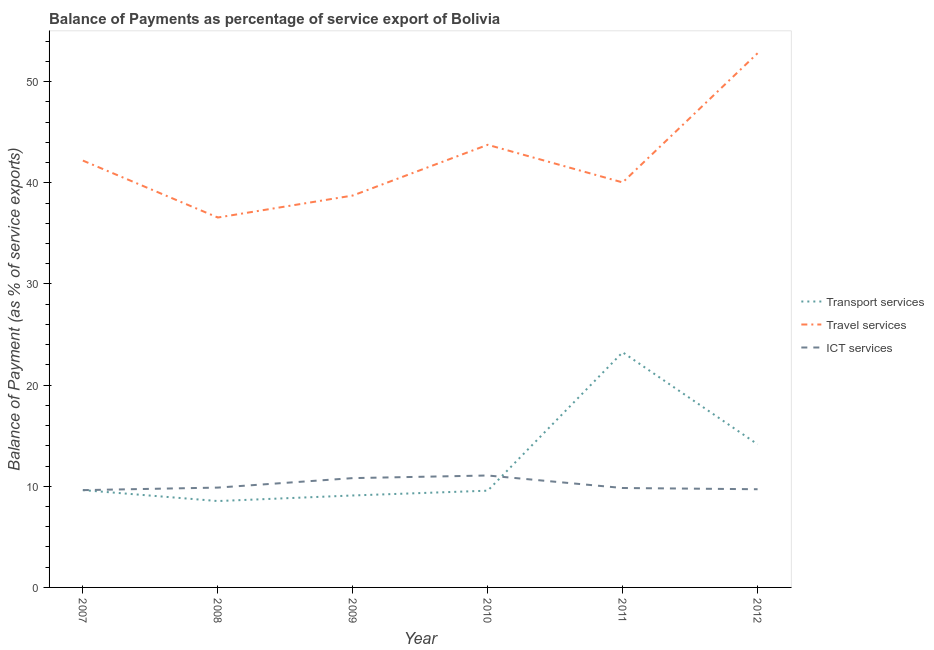What is the balance of payment of transport services in 2010?
Offer a terse response. 9.57. Across all years, what is the maximum balance of payment of ict services?
Keep it short and to the point. 11.07. Across all years, what is the minimum balance of payment of transport services?
Provide a short and direct response. 8.54. In which year was the balance of payment of ict services maximum?
Offer a very short reply. 2010. In which year was the balance of payment of transport services minimum?
Your response must be concise. 2008. What is the total balance of payment of transport services in the graph?
Offer a terse response. 74.21. What is the difference between the balance of payment of transport services in 2007 and that in 2011?
Your response must be concise. -13.63. What is the difference between the balance of payment of transport services in 2012 and the balance of payment of travel services in 2009?
Provide a succinct answer. -24.6. What is the average balance of payment of ict services per year?
Offer a terse response. 10.15. In the year 2009, what is the difference between the balance of payment of transport services and balance of payment of ict services?
Your answer should be compact. -1.72. What is the ratio of the balance of payment of travel services in 2008 to that in 2012?
Offer a very short reply. 0.69. Is the difference between the balance of payment of travel services in 2007 and 2012 greater than the difference between the balance of payment of transport services in 2007 and 2012?
Provide a succinct answer. No. What is the difference between the highest and the second highest balance of payment of transport services?
Make the answer very short. 9.1. What is the difference between the highest and the lowest balance of payment of transport services?
Offer a very short reply. 14.71. Is it the case that in every year, the sum of the balance of payment of transport services and balance of payment of travel services is greater than the balance of payment of ict services?
Offer a very short reply. Yes. Does the balance of payment of transport services monotonically increase over the years?
Your response must be concise. No. Is the balance of payment of ict services strictly greater than the balance of payment of transport services over the years?
Ensure brevity in your answer.  No. Is the balance of payment of ict services strictly less than the balance of payment of travel services over the years?
Keep it short and to the point. Yes. How many lines are there?
Ensure brevity in your answer.  3. What is the difference between two consecutive major ticks on the Y-axis?
Give a very brief answer. 10. Are the values on the major ticks of Y-axis written in scientific E-notation?
Give a very brief answer. No. Does the graph contain grids?
Keep it short and to the point. No. Where does the legend appear in the graph?
Give a very brief answer. Center right. How many legend labels are there?
Your answer should be very brief. 3. How are the legend labels stacked?
Ensure brevity in your answer.  Vertical. What is the title of the graph?
Your response must be concise. Balance of Payments as percentage of service export of Bolivia. Does "Labor Tax" appear as one of the legend labels in the graph?
Your answer should be very brief. No. What is the label or title of the X-axis?
Provide a succinct answer. Year. What is the label or title of the Y-axis?
Your response must be concise. Balance of Payment (as % of service exports). What is the Balance of Payment (as % of service exports) of Transport services in 2007?
Keep it short and to the point. 9.62. What is the Balance of Payment (as % of service exports) in Travel services in 2007?
Provide a succinct answer. 42.2. What is the Balance of Payment (as % of service exports) in ICT services in 2007?
Your response must be concise. 9.62. What is the Balance of Payment (as % of service exports) in Transport services in 2008?
Make the answer very short. 8.54. What is the Balance of Payment (as % of service exports) in Travel services in 2008?
Provide a short and direct response. 36.57. What is the Balance of Payment (as % of service exports) of ICT services in 2008?
Ensure brevity in your answer.  9.87. What is the Balance of Payment (as % of service exports) of Transport services in 2009?
Give a very brief answer. 9.09. What is the Balance of Payment (as % of service exports) in Travel services in 2009?
Your response must be concise. 38.75. What is the Balance of Payment (as % of service exports) of ICT services in 2009?
Your answer should be very brief. 10.81. What is the Balance of Payment (as % of service exports) of Transport services in 2010?
Offer a terse response. 9.57. What is the Balance of Payment (as % of service exports) in Travel services in 2010?
Offer a terse response. 43.76. What is the Balance of Payment (as % of service exports) of ICT services in 2010?
Provide a succinct answer. 11.07. What is the Balance of Payment (as % of service exports) of Transport services in 2011?
Make the answer very short. 23.25. What is the Balance of Payment (as % of service exports) in Travel services in 2011?
Ensure brevity in your answer.  40.04. What is the Balance of Payment (as % of service exports) in ICT services in 2011?
Offer a terse response. 9.83. What is the Balance of Payment (as % of service exports) in Transport services in 2012?
Ensure brevity in your answer.  14.15. What is the Balance of Payment (as % of service exports) in Travel services in 2012?
Provide a short and direct response. 52.82. What is the Balance of Payment (as % of service exports) of ICT services in 2012?
Provide a short and direct response. 9.71. Across all years, what is the maximum Balance of Payment (as % of service exports) in Transport services?
Make the answer very short. 23.25. Across all years, what is the maximum Balance of Payment (as % of service exports) in Travel services?
Make the answer very short. 52.82. Across all years, what is the maximum Balance of Payment (as % of service exports) in ICT services?
Provide a short and direct response. 11.07. Across all years, what is the minimum Balance of Payment (as % of service exports) in Transport services?
Your answer should be compact. 8.54. Across all years, what is the minimum Balance of Payment (as % of service exports) of Travel services?
Provide a succinct answer. 36.57. Across all years, what is the minimum Balance of Payment (as % of service exports) in ICT services?
Provide a short and direct response. 9.62. What is the total Balance of Payment (as % of service exports) in Transport services in the graph?
Keep it short and to the point. 74.21. What is the total Balance of Payment (as % of service exports) of Travel services in the graph?
Provide a short and direct response. 254.14. What is the total Balance of Payment (as % of service exports) in ICT services in the graph?
Offer a very short reply. 60.9. What is the difference between the Balance of Payment (as % of service exports) in Transport services in 2007 and that in 2008?
Keep it short and to the point. 1.08. What is the difference between the Balance of Payment (as % of service exports) in Travel services in 2007 and that in 2008?
Provide a succinct answer. 5.63. What is the difference between the Balance of Payment (as % of service exports) of ICT services in 2007 and that in 2008?
Your answer should be compact. -0.25. What is the difference between the Balance of Payment (as % of service exports) in Transport services in 2007 and that in 2009?
Ensure brevity in your answer.  0.53. What is the difference between the Balance of Payment (as % of service exports) of Travel services in 2007 and that in 2009?
Offer a very short reply. 3.46. What is the difference between the Balance of Payment (as % of service exports) in ICT services in 2007 and that in 2009?
Your answer should be very brief. -1.19. What is the difference between the Balance of Payment (as % of service exports) in Transport services in 2007 and that in 2010?
Keep it short and to the point. 0.06. What is the difference between the Balance of Payment (as % of service exports) of Travel services in 2007 and that in 2010?
Keep it short and to the point. -1.56. What is the difference between the Balance of Payment (as % of service exports) of ICT services in 2007 and that in 2010?
Your answer should be very brief. -1.45. What is the difference between the Balance of Payment (as % of service exports) of Transport services in 2007 and that in 2011?
Keep it short and to the point. -13.63. What is the difference between the Balance of Payment (as % of service exports) of Travel services in 2007 and that in 2011?
Give a very brief answer. 2.16. What is the difference between the Balance of Payment (as % of service exports) of ICT services in 2007 and that in 2011?
Your answer should be compact. -0.21. What is the difference between the Balance of Payment (as % of service exports) of Transport services in 2007 and that in 2012?
Your answer should be compact. -4.53. What is the difference between the Balance of Payment (as % of service exports) in Travel services in 2007 and that in 2012?
Give a very brief answer. -10.61. What is the difference between the Balance of Payment (as % of service exports) in ICT services in 2007 and that in 2012?
Keep it short and to the point. -0.09. What is the difference between the Balance of Payment (as % of service exports) of Transport services in 2008 and that in 2009?
Your answer should be very brief. -0.55. What is the difference between the Balance of Payment (as % of service exports) of Travel services in 2008 and that in 2009?
Keep it short and to the point. -2.17. What is the difference between the Balance of Payment (as % of service exports) in ICT services in 2008 and that in 2009?
Your response must be concise. -0.94. What is the difference between the Balance of Payment (as % of service exports) of Transport services in 2008 and that in 2010?
Provide a succinct answer. -1.03. What is the difference between the Balance of Payment (as % of service exports) of Travel services in 2008 and that in 2010?
Provide a short and direct response. -7.19. What is the difference between the Balance of Payment (as % of service exports) in ICT services in 2008 and that in 2010?
Offer a very short reply. -1.2. What is the difference between the Balance of Payment (as % of service exports) of Transport services in 2008 and that in 2011?
Make the answer very short. -14.71. What is the difference between the Balance of Payment (as % of service exports) in Travel services in 2008 and that in 2011?
Provide a succinct answer. -3.47. What is the difference between the Balance of Payment (as % of service exports) in ICT services in 2008 and that in 2011?
Make the answer very short. 0.04. What is the difference between the Balance of Payment (as % of service exports) in Transport services in 2008 and that in 2012?
Your response must be concise. -5.61. What is the difference between the Balance of Payment (as % of service exports) in Travel services in 2008 and that in 2012?
Provide a succinct answer. -16.24. What is the difference between the Balance of Payment (as % of service exports) of ICT services in 2008 and that in 2012?
Offer a very short reply. 0.16. What is the difference between the Balance of Payment (as % of service exports) in Transport services in 2009 and that in 2010?
Give a very brief answer. -0.47. What is the difference between the Balance of Payment (as % of service exports) in Travel services in 2009 and that in 2010?
Offer a very short reply. -5.02. What is the difference between the Balance of Payment (as % of service exports) in ICT services in 2009 and that in 2010?
Offer a very short reply. -0.26. What is the difference between the Balance of Payment (as % of service exports) in Transport services in 2009 and that in 2011?
Your answer should be compact. -14.16. What is the difference between the Balance of Payment (as % of service exports) of Travel services in 2009 and that in 2011?
Offer a terse response. -1.3. What is the difference between the Balance of Payment (as % of service exports) in ICT services in 2009 and that in 2011?
Offer a very short reply. 0.98. What is the difference between the Balance of Payment (as % of service exports) in Transport services in 2009 and that in 2012?
Your answer should be compact. -5.06. What is the difference between the Balance of Payment (as % of service exports) of Travel services in 2009 and that in 2012?
Your response must be concise. -14.07. What is the difference between the Balance of Payment (as % of service exports) in ICT services in 2009 and that in 2012?
Give a very brief answer. 1.1. What is the difference between the Balance of Payment (as % of service exports) of Transport services in 2010 and that in 2011?
Your answer should be compact. -13.68. What is the difference between the Balance of Payment (as % of service exports) in Travel services in 2010 and that in 2011?
Keep it short and to the point. 3.72. What is the difference between the Balance of Payment (as % of service exports) in ICT services in 2010 and that in 2011?
Your response must be concise. 1.24. What is the difference between the Balance of Payment (as % of service exports) in Transport services in 2010 and that in 2012?
Keep it short and to the point. -4.58. What is the difference between the Balance of Payment (as % of service exports) of Travel services in 2010 and that in 2012?
Provide a short and direct response. -9.06. What is the difference between the Balance of Payment (as % of service exports) of ICT services in 2010 and that in 2012?
Your response must be concise. 1.36. What is the difference between the Balance of Payment (as % of service exports) of Transport services in 2011 and that in 2012?
Offer a very short reply. 9.1. What is the difference between the Balance of Payment (as % of service exports) of Travel services in 2011 and that in 2012?
Ensure brevity in your answer.  -12.78. What is the difference between the Balance of Payment (as % of service exports) in ICT services in 2011 and that in 2012?
Provide a short and direct response. 0.12. What is the difference between the Balance of Payment (as % of service exports) in Transport services in 2007 and the Balance of Payment (as % of service exports) in Travel services in 2008?
Keep it short and to the point. -26.95. What is the difference between the Balance of Payment (as % of service exports) of Transport services in 2007 and the Balance of Payment (as % of service exports) of ICT services in 2008?
Keep it short and to the point. -0.25. What is the difference between the Balance of Payment (as % of service exports) of Travel services in 2007 and the Balance of Payment (as % of service exports) of ICT services in 2008?
Make the answer very short. 32.33. What is the difference between the Balance of Payment (as % of service exports) in Transport services in 2007 and the Balance of Payment (as % of service exports) in Travel services in 2009?
Keep it short and to the point. -29.12. What is the difference between the Balance of Payment (as % of service exports) in Transport services in 2007 and the Balance of Payment (as % of service exports) in ICT services in 2009?
Your answer should be compact. -1.19. What is the difference between the Balance of Payment (as % of service exports) of Travel services in 2007 and the Balance of Payment (as % of service exports) of ICT services in 2009?
Give a very brief answer. 31.39. What is the difference between the Balance of Payment (as % of service exports) in Transport services in 2007 and the Balance of Payment (as % of service exports) in Travel services in 2010?
Offer a terse response. -34.14. What is the difference between the Balance of Payment (as % of service exports) of Transport services in 2007 and the Balance of Payment (as % of service exports) of ICT services in 2010?
Give a very brief answer. -1.45. What is the difference between the Balance of Payment (as % of service exports) in Travel services in 2007 and the Balance of Payment (as % of service exports) in ICT services in 2010?
Make the answer very short. 31.14. What is the difference between the Balance of Payment (as % of service exports) of Transport services in 2007 and the Balance of Payment (as % of service exports) of Travel services in 2011?
Give a very brief answer. -30.42. What is the difference between the Balance of Payment (as % of service exports) in Transport services in 2007 and the Balance of Payment (as % of service exports) in ICT services in 2011?
Your response must be concise. -0.21. What is the difference between the Balance of Payment (as % of service exports) of Travel services in 2007 and the Balance of Payment (as % of service exports) of ICT services in 2011?
Offer a very short reply. 32.37. What is the difference between the Balance of Payment (as % of service exports) of Transport services in 2007 and the Balance of Payment (as % of service exports) of Travel services in 2012?
Provide a short and direct response. -43.2. What is the difference between the Balance of Payment (as % of service exports) in Transport services in 2007 and the Balance of Payment (as % of service exports) in ICT services in 2012?
Your response must be concise. -0.09. What is the difference between the Balance of Payment (as % of service exports) in Travel services in 2007 and the Balance of Payment (as % of service exports) in ICT services in 2012?
Your response must be concise. 32.49. What is the difference between the Balance of Payment (as % of service exports) of Transport services in 2008 and the Balance of Payment (as % of service exports) of Travel services in 2009?
Provide a short and direct response. -30.21. What is the difference between the Balance of Payment (as % of service exports) in Transport services in 2008 and the Balance of Payment (as % of service exports) in ICT services in 2009?
Keep it short and to the point. -2.27. What is the difference between the Balance of Payment (as % of service exports) of Travel services in 2008 and the Balance of Payment (as % of service exports) of ICT services in 2009?
Provide a succinct answer. 25.76. What is the difference between the Balance of Payment (as % of service exports) of Transport services in 2008 and the Balance of Payment (as % of service exports) of Travel services in 2010?
Offer a very short reply. -35.22. What is the difference between the Balance of Payment (as % of service exports) in Transport services in 2008 and the Balance of Payment (as % of service exports) in ICT services in 2010?
Make the answer very short. -2.53. What is the difference between the Balance of Payment (as % of service exports) in Travel services in 2008 and the Balance of Payment (as % of service exports) in ICT services in 2010?
Ensure brevity in your answer.  25.51. What is the difference between the Balance of Payment (as % of service exports) of Transport services in 2008 and the Balance of Payment (as % of service exports) of Travel services in 2011?
Your answer should be very brief. -31.5. What is the difference between the Balance of Payment (as % of service exports) in Transport services in 2008 and the Balance of Payment (as % of service exports) in ICT services in 2011?
Provide a short and direct response. -1.29. What is the difference between the Balance of Payment (as % of service exports) of Travel services in 2008 and the Balance of Payment (as % of service exports) of ICT services in 2011?
Give a very brief answer. 26.74. What is the difference between the Balance of Payment (as % of service exports) in Transport services in 2008 and the Balance of Payment (as % of service exports) in Travel services in 2012?
Your answer should be compact. -44.28. What is the difference between the Balance of Payment (as % of service exports) in Transport services in 2008 and the Balance of Payment (as % of service exports) in ICT services in 2012?
Give a very brief answer. -1.17. What is the difference between the Balance of Payment (as % of service exports) in Travel services in 2008 and the Balance of Payment (as % of service exports) in ICT services in 2012?
Give a very brief answer. 26.86. What is the difference between the Balance of Payment (as % of service exports) in Transport services in 2009 and the Balance of Payment (as % of service exports) in Travel services in 2010?
Your response must be concise. -34.67. What is the difference between the Balance of Payment (as % of service exports) of Transport services in 2009 and the Balance of Payment (as % of service exports) of ICT services in 2010?
Give a very brief answer. -1.98. What is the difference between the Balance of Payment (as % of service exports) in Travel services in 2009 and the Balance of Payment (as % of service exports) in ICT services in 2010?
Give a very brief answer. 27.68. What is the difference between the Balance of Payment (as % of service exports) of Transport services in 2009 and the Balance of Payment (as % of service exports) of Travel services in 2011?
Your answer should be compact. -30.95. What is the difference between the Balance of Payment (as % of service exports) of Transport services in 2009 and the Balance of Payment (as % of service exports) of ICT services in 2011?
Offer a very short reply. -0.74. What is the difference between the Balance of Payment (as % of service exports) in Travel services in 2009 and the Balance of Payment (as % of service exports) in ICT services in 2011?
Provide a succinct answer. 28.92. What is the difference between the Balance of Payment (as % of service exports) of Transport services in 2009 and the Balance of Payment (as % of service exports) of Travel services in 2012?
Your answer should be very brief. -43.73. What is the difference between the Balance of Payment (as % of service exports) of Transport services in 2009 and the Balance of Payment (as % of service exports) of ICT services in 2012?
Provide a succinct answer. -0.62. What is the difference between the Balance of Payment (as % of service exports) of Travel services in 2009 and the Balance of Payment (as % of service exports) of ICT services in 2012?
Provide a short and direct response. 29.04. What is the difference between the Balance of Payment (as % of service exports) of Transport services in 2010 and the Balance of Payment (as % of service exports) of Travel services in 2011?
Your response must be concise. -30.48. What is the difference between the Balance of Payment (as % of service exports) of Transport services in 2010 and the Balance of Payment (as % of service exports) of ICT services in 2011?
Offer a very short reply. -0.26. What is the difference between the Balance of Payment (as % of service exports) in Travel services in 2010 and the Balance of Payment (as % of service exports) in ICT services in 2011?
Your answer should be compact. 33.93. What is the difference between the Balance of Payment (as % of service exports) in Transport services in 2010 and the Balance of Payment (as % of service exports) in Travel services in 2012?
Offer a very short reply. -43.25. What is the difference between the Balance of Payment (as % of service exports) of Transport services in 2010 and the Balance of Payment (as % of service exports) of ICT services in 2012?
Give a very brief answer. -0.14. What is the difference between the Balance of Payment (as % of service exports) in Travel services in 2010 and the Balance of Payment (as % of service exports) in ICT services in 2012?
Make the answer very short. 34.05. What is the difference between the Balance of Payment (as % of service exports) in Transport services in 2011 and the Balance of Payment (as % of service exports) in Travel services in 2012?
Your response must be concise. -29.57. What is the difference between the Balance of Payment (as % of service exports) in Transport services in 2011 and the Balance of Payment (as % of service exports) in ICT services in 2012?
Your answer should be very brief. 13.54. What is the difference between the Balance of Payment (as % of service exports) of Travel services in 2011 and the Balance of Payment (as % of service exports) of ICT services in 2012?
Your answer should be very brief. 30.33. What is the average Balance of Payment (as % of service exports) in Transport services per year?
Your response must be concise. 12.37. What is the average Balance of Payment (as % of service exports) in Travel services per year?
Offer a terse response. 42.36. What is the average Balance of Payment (as % of service exports) of ICT services per year?
Your response must be concise. 10.15. In the year 2007, what is the difference between the Balance of Payment (as % of service exports) in Transport services and Balance of Payment (as % of service exports) in Travel services?
Provide a short and direct response. -32.58. In the year 2007, what is the difference between the Balance of Payment (as % of service exports) of Transport services and Balance of Payment (as % of service exports) of ICT services?
Offer a very short reply. 0. In the year 2007, what is the difference between the Balance of Payment (as % of service exports) in Travel services and Balance of Payment (as % of service exports) in ICT services?
Offer a very short reply. 32.58. In the year 2008, what is the difference between the Balance of Payment (as % of service exports) in Transport services and Balance of Payment (as % of service exports) in Travel services?
Provide a succinct answer. -28.03. In the year 2008, what is the difference between the Balance of Payment (as % of service exports) in Transport services and Balance of Payment (as % of service exports) in ICT services?
Offer a terse response. -1.33. In the year 2008, what is the difference between the Balance of Payment (as % of service exports) in Travel services and Balance of Payment (as % of service exports) in ICT services?
Your answer should be compact. 26.7. In the year 2009, what is the difference between the Balance of Payment (as % of service exports) in Transport services and Balance of Payment (as % of service exports) in Travel services?
Ensure brevity in your answer.  -29.65. In the year 2009, what is the difference between the Balance of Payment (as % of service exports) in Transport services and Balance of Payment (as % of service exports) in ICT services?
Ensure brevity in your answer.  -1.72. In the year 2009, what is the difference between the Balance of Payment (as % of service exports) of Travel services and Balance of Payment (as % of service exports) of ICT services?
Your answer should be very brief. 27.94. In the year 2010, what is the difference between the Balance of Payment (as % of service exports) in Transport services and Balance of Payment (as % of service exports) in Travel services?
Your answer should be compact. -34.2. In the year 2010, what is the difference between the Balance of Payment (as % of service exports) of Transport services and Balance of Payment (as % of service exports) of ICT services?
Keep it short and to the point. -1.5. In the year 2010, what is the difference between the Balance of Payment (as % of service exports) of Travel services and Balance of Payment (as % of service exports) of ICT services?
Offer a very short reply. 32.69. In the year 2011, what is the difference between the Balance of Payment (as % of service exports) of Transport services and Balance of Payment (as % of service exports) of Travel services?
Make the answer very short. -16.79. In the year 2011, what is the difference between the Balance of Payment (as % of service exports) of Transport services and Balance of Payment (as % of service exports) of ICT services?
Provide a short and direct response. 13.42. In the year 2011, what is the difference between the Balance of Payment (as % of service exports) in Travel services and Balance of Payment (as % of service exports) in ICT services?
Provide a short and direct response. 30.21. In the year 2012, what is the difference between the Balance of Payment (as % of service exports) in Transport services and Balance of Payment (as % of service exports) in Travel services?
Make the answer very short. -38.67. In the year 2012, what is the difference between the Balance of Payment (as % of service exports) of Transport services and Balance of Payment (as % of service exports) of ICT services?
Offer a terse response. 4.44. In the year 2012, what is the difference between the Balance of Payment (as % of service exports) in Travel services and Balance of Payment (as % of service exports) in ICT services?
Provide a short and direct response. 43.11. What is the ratio of the Balance of Payment (as % of service exports) of Transport services in 2007 to that in 2008?
Give a very brief answer. 1.13. What is the ratio of the Balance of Payment (as % of service exports) in Travel services in 2007 to that in 2008?
Offer a very short reply. 1.15. What is the ratio of the Balance of Payment (as % of service exports) of ICT services in 2007 to that in 2008?
Keep it short and to the point. 0.97. What is the ratio of the Balance of Payment (as % of service exports) of Transport services in 2007 to that in 2009?
Keep it short and to the point. 1.06. What is the ratio of the Balance of Payment (as % of service exports) in Travel services in 2007 to that in 2009?
Keep it short and to the point. 1.09. What is the ratio of the Balance of Payment (as % of service exports) of ICT services in 2007 to that in 2009?
Give a very brief answer. 0.89. What is the ratio of the Balance of Payment (as % of service exports) in Transport services in 2007 to that in 2010?
Provide a succinct answer. 1.01. What is the ratio of the Balance of Payment (as % of service exports) of Travel services in 2007 to that in 2010?
Provide a short and direct response. 0.96. What is the ratio of the Balance of Payment (as % of service exports) of ICT services in 2007 to that in 2010?
Provide a short and direct response. 0.87. What is the ratio of the Balance of Payment (as % of service exports) of Transport services in 2007 to that in 2011?
Your response must be concise. 0.41. What is the ratio of the Balance of Payment (as % of service exports) of Travel services in 2007 to that in 2011?
Provide a succinct answer. 1.05. What is the ratio of the Balance of Payment (as % of service exports) of ICT services in 2007 to that in 2011?
Offer a terse response. 0.98. What is the ratio of the Balance of Payment (as % of service exports) of Transport services in 2007 to that in 2012?
Offer a terse response. 0.68. What is the ratio of the Balance of Payment (as % of service exports) of Travel services in 2007 to that in 2012?
Give a very brief answer. 0.8. What is the ratio of the Balance of Payment (as % of service exports) of ICT services in 2007 to that in 2012?
Your answer should be very brief. 0.99. What is the ratio of the Balance of Payment (as % of service exports) in Transport services in 2008 to that in 2009?
Your answer should be very brief. 0.94. What is the ratio of the Balance of Payment (as % of service exports) in Travel services in 2008 to that in 2009?
Ensure brevity in your answer.  0.94. What is the ratio of the Balance of Payment (as % of service exports) of ICT services in 2008 to that in 2009?
Offer a very short reply. 0.91. What is the ratio of the Balance of Payment (as % of service exports) in Transport services in 2008 to that in 2010?
Keep it short and to the point. 0.89. What is the ratio of the Balance of Payment (as % of service exports) of Travel services in 2008 to that in 2010?
Provide a short and direct response. 0.84. What is the ratio of the Balance of Payment (as % of service exports) in ICT services in 2008 to that in 2010?
Give a very brief answer. 0.89. What is the ratio of the Balance of Payment (as % of service exports) in Transport services in 2008 to that in 2011?
Give a very brief answer. 0.37. What is the ratio of the Balance of Payment (as % of service exports) in Travel services in 2008 to that in 2011?
Make the answer very short. 0.91. What is the ratio of the Balance of Payment (as % of service exports) of ICT services in 2008 to that in 2011?
Your response must be concise. 1. What is the ratio of the Balance of Payment (as % of service exports) of Transport services in 2008 to that in 2012?
Your answer should be compact. 0.6. What is the ratio of the Balance of Payment (as % of service exports) of Travel services in 2008 to that in 2012?
Give a very brief answer. 0.69. What is the ratio of the Balance of Payment (as % of service exports) in ICT services in 2008 to that in 2012?
Give a very brief answer. 1.02. What is the ratio of the Balance of Payment (as % of service exports) of Transport services in 2009 to that in 2010?
Your answer should be compact. 0.95. What is the ratio of the Balance of Payment (as % of service exports) in Travel services in 2009 to that in 2010?
Your answer should be very brief. 0.89. What is the ratio of the Balance of Payment (as % of service exports) of ICT services in 2009 to that in 2010?
Offer a very short reply. 0.98. What is the ratio of the Balance of Payment (as % of service exports) in Transport services in 2009 to that in 2011?
Your response must be concise. 0.39. What is the ratio of the Balance of Payment (as % of service exports) of Travel services in 2009 to that in 2011?
Make the answer very short. 0.97. What is the ratio of the Balance of Payment (as % of service exports) in ICT services in 2009 to that in 2011?
Provide a short and direct response. 1.1. What is the ratio of the Balance of Payment (as % of service exports) of Transport services in 2009 to that in 2012?
Ensure brevity in your answer.  0.64. What is the ratio of the Balance of Payment (as % of service exports) in Travel services in 2009 to that in 2012?
Offer a terse response. 0.73. What is the ratio of the Balance of Payment (as % of service exports) of ICT services in 2009 to that in 2012?
Provide a short and direct response. 1.11. What is the ratio of the Balance of Payment (as % of service exports) of Transport services in 2010 to that in 2011?
Provide a short and direct response. 0.41. What is the ratio of the Balance of Payment (as % of service exports) of Travel services in 2010 to that in 2011?
Your answer should be compact. 1.09. What is the ratio of the Balance of Payment (as % of service exports) in ICT services in 2010 to that in 2011?
Your answer should be compact. 1.13. What is the ratio of the Balance of Payment (as % of service exports) of Transport services in 2010 to that in 2012?
Keep it short and to the point. 0.68. What is the ratio of the Balance of Payment (as % of service exports) of Travel services in 2010 to that in 2012?
Ensure brevity in your answer.  0.83. What is the ratio of the Balance of Payment (as % of service exports) of ICT services in 2010 to that in 2012?
Keep it short and to the point. 1.14. What is the ratio of the Balance of Payment (as % of service exports) in Transport services in 2011 to that in 2012?
Make the answer very short. 1.64. What is the ratio of the Balance of Payment (as % of service exports) in Travel services in 2011 to that in 2012?
Offer a terse response. 0.76. What is the ratio of the Balance of Payment (as % of service exports) in ICT services in 2011 to that in 2012?
Your response must be concise. 1.01. What is the difference between the highest and the second highest Balance of Payment (as % of service exports) of Transport services?
Your answer should be very brief. 9.1. What is the difference between the highest and the second highest Balance of Payment (as % of service exports) of Travel services?
Provide a short and direct response. 9.06. What is the difference between the highest and the second highest Balance of Payment (as % of service exports) of ICT services?
Give a very brief answer. 0.26. What is the difference between the highest and the lowest Balance of Payment (as % of service exports) of Transport services?
Offer a terse response. 14.71. What is the difference between the highest and the lowest Balance of Payment (as % of service exports) in Travel services?
Your response must be concise. 16.24. What is the difference between the highest and the lowest Balance of Payment (as % of service exports) of ICT services?
Keep it short and to the point. 1.45. 